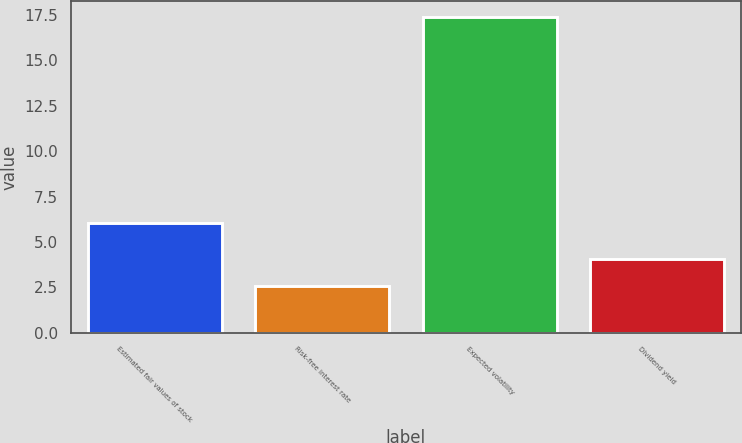<chart> <loc_0><loc_0><loc_500><loc_500><bar_chart><fcel>Estimated fair values of stock<fcel>Risk-free interest rate<fcel>Expected volatility<fcel>Dividend yield<nl><fcel>6.03<fcel>2.6<fcel>17.4<fcel>4.08<nl></chart> 